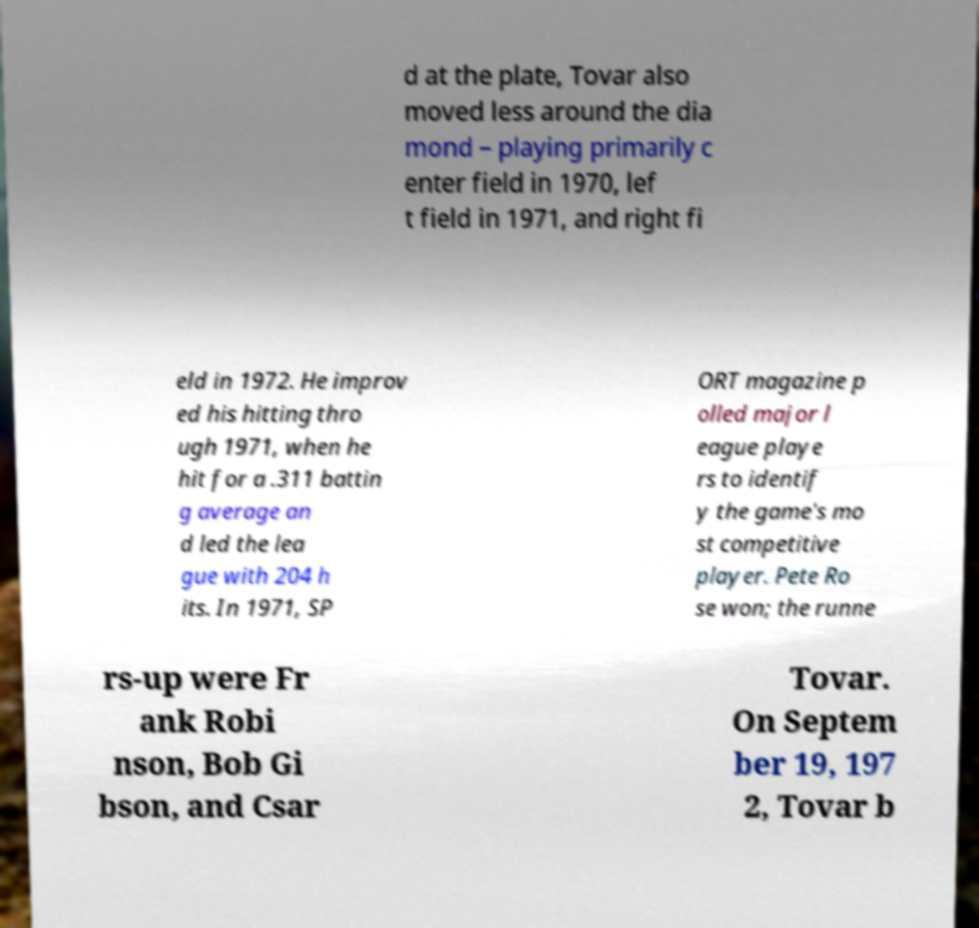There's text embedded in this image that I need extracted. Can you transcribe it verbatim? d at the plate, Tovar also moved less around the dia mond – playing primarily c enter field in 1970, lef t field in 1971, and right fi eld in 1972. He improv ed his hitting thro ugh 1971, when he hit for a .311 battin g average an d led the lea gue with 204 h its. In 1971, SP ORT magazine p olled major l eague playe rs to identif y the game's mo st competitive player. Pete Ro se won; the runne rs-up were Fr ank Robi nson, Bob Gi bson, and Csar Tovar. On Septem ber 19, 197 2, Tovar b 